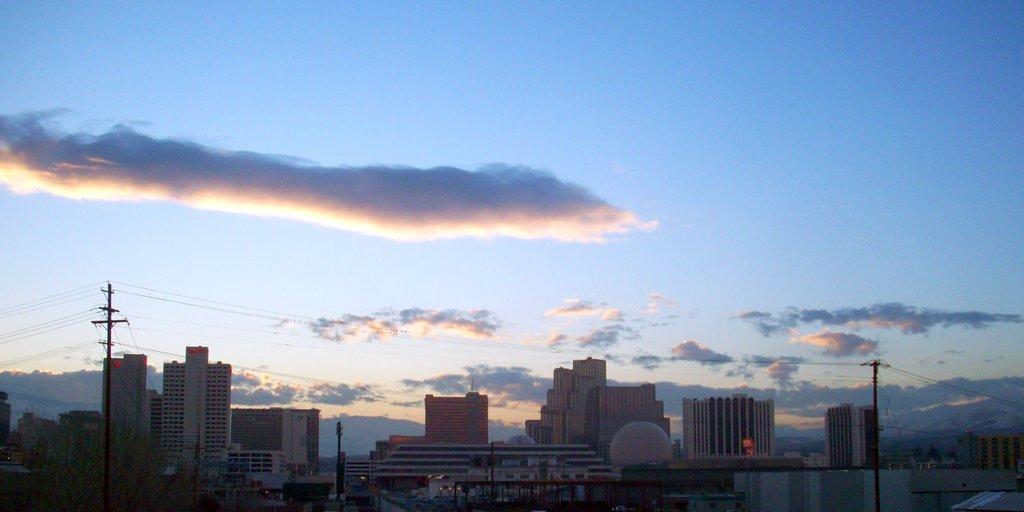Please provide a concise description of this image. In this image there are buildings one beside the other at the bottom. At the top there is the sky. On the left side there is an electric pole to which there are there are wires. On the right side there is another pole to which there are wires. 